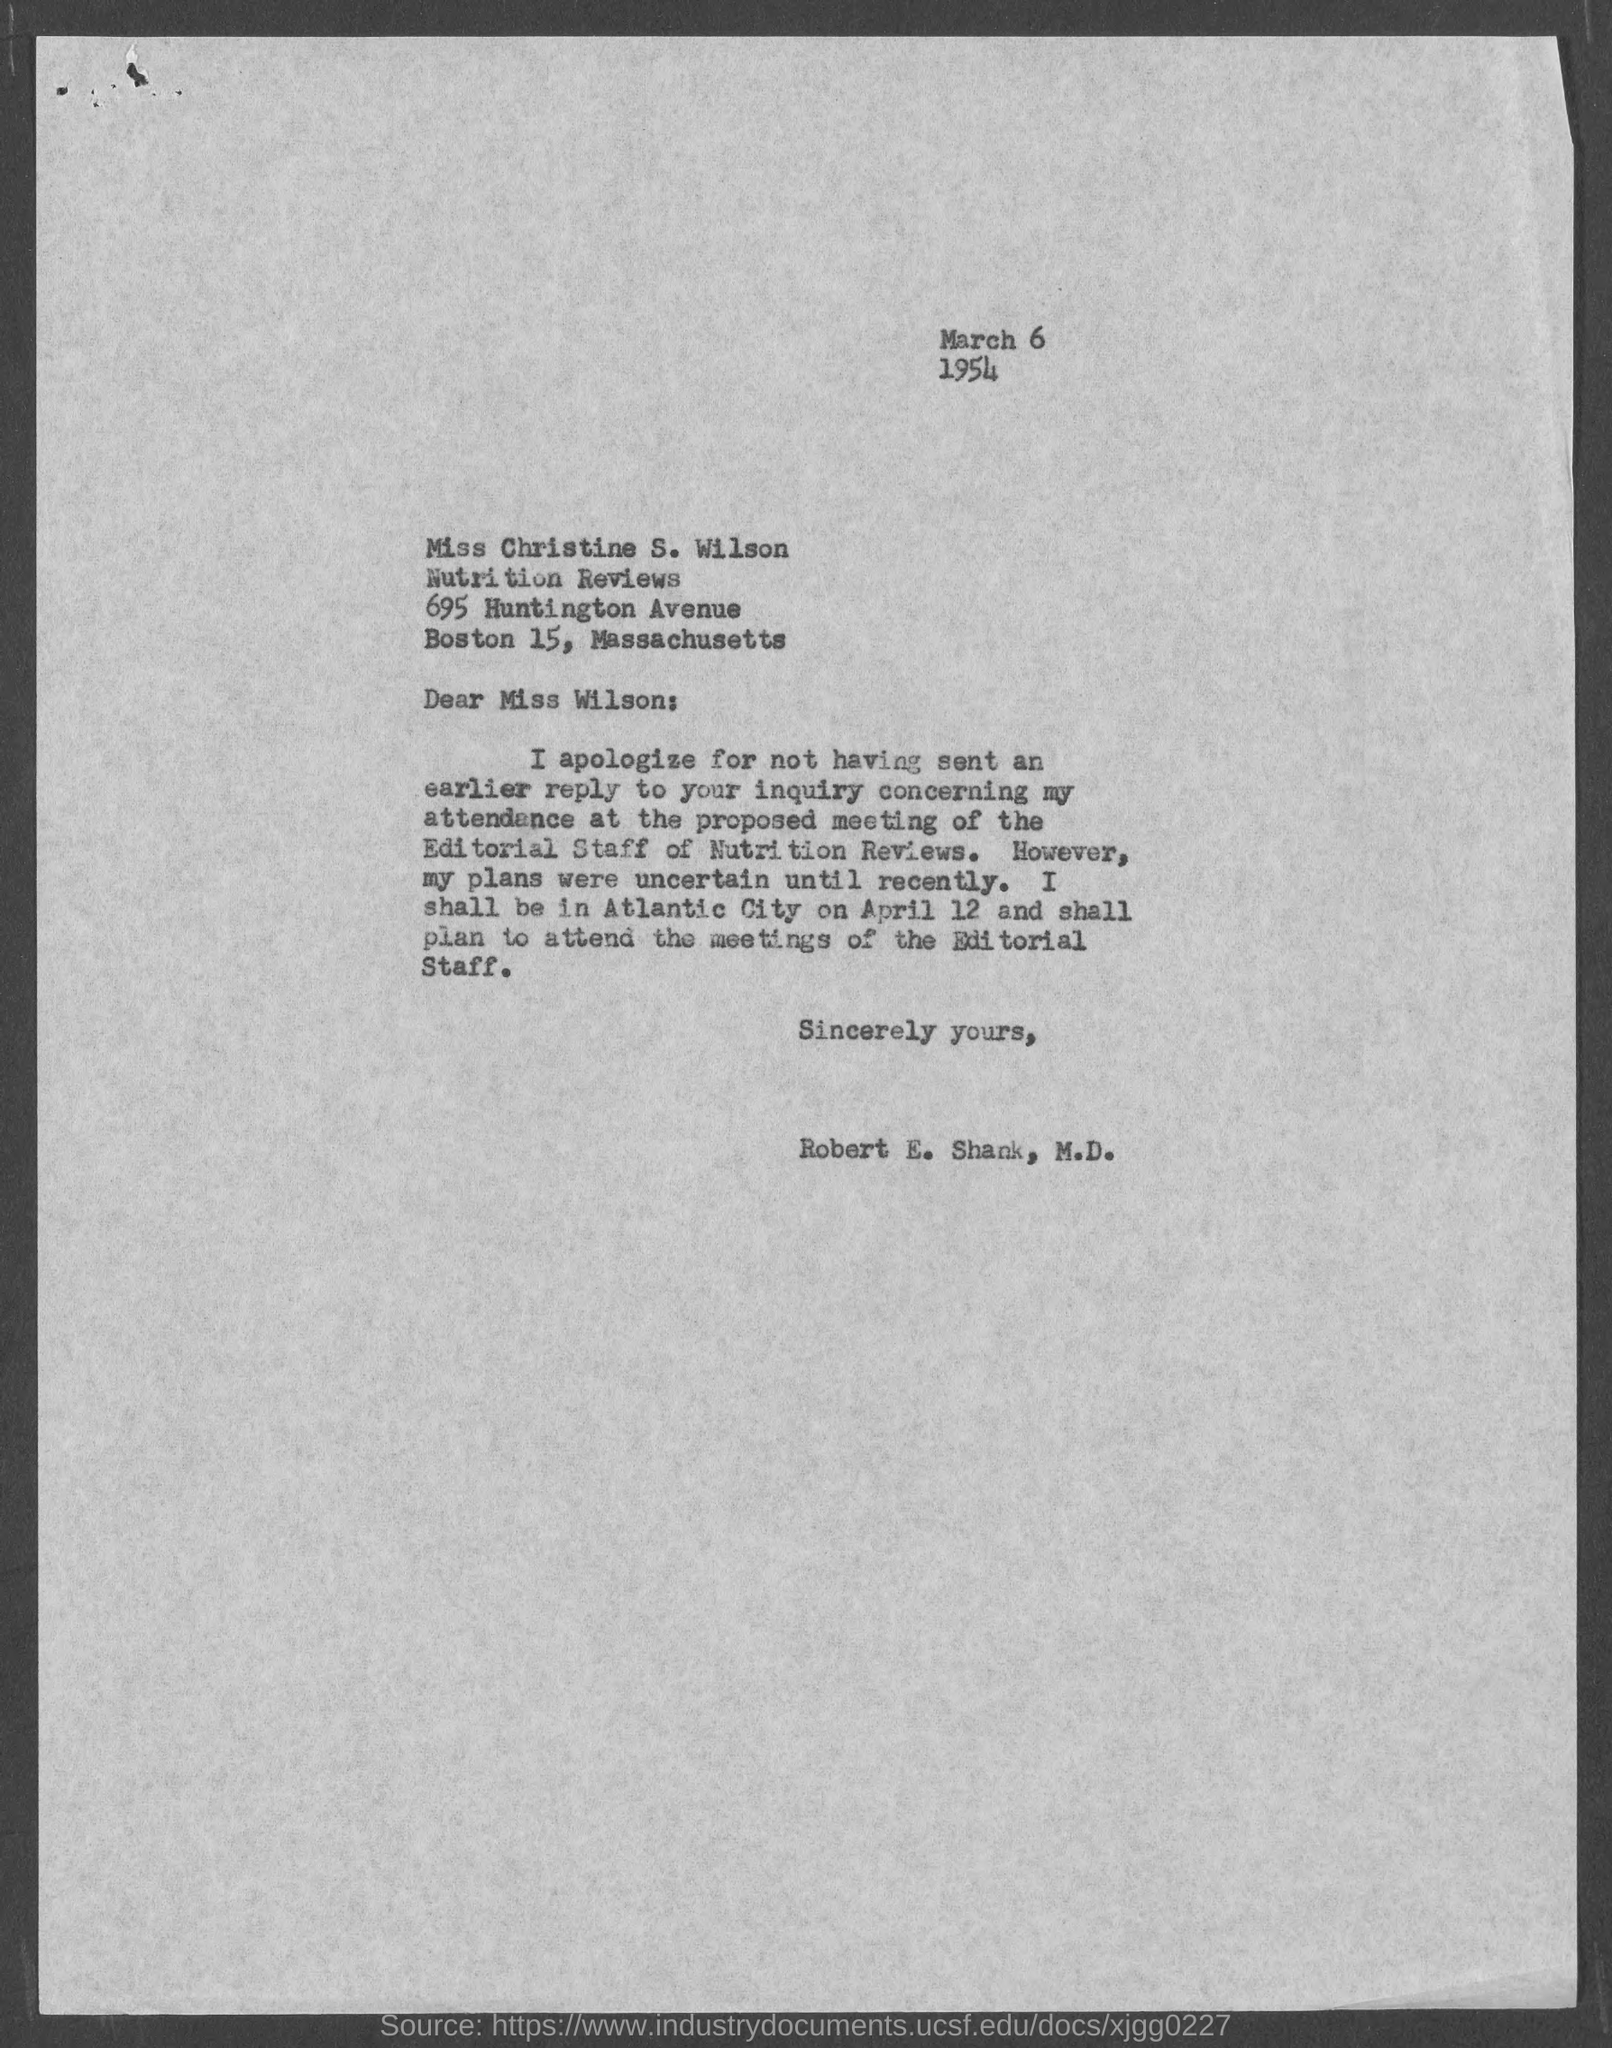What is the date on the document?
Your answer should be compact. March 6 1954. To Whom is this letter addressed to?
Your answer should be compact. Miss wilson. Who is this letter from?
Offer a terse response. Robert E. Shank, M.D. 